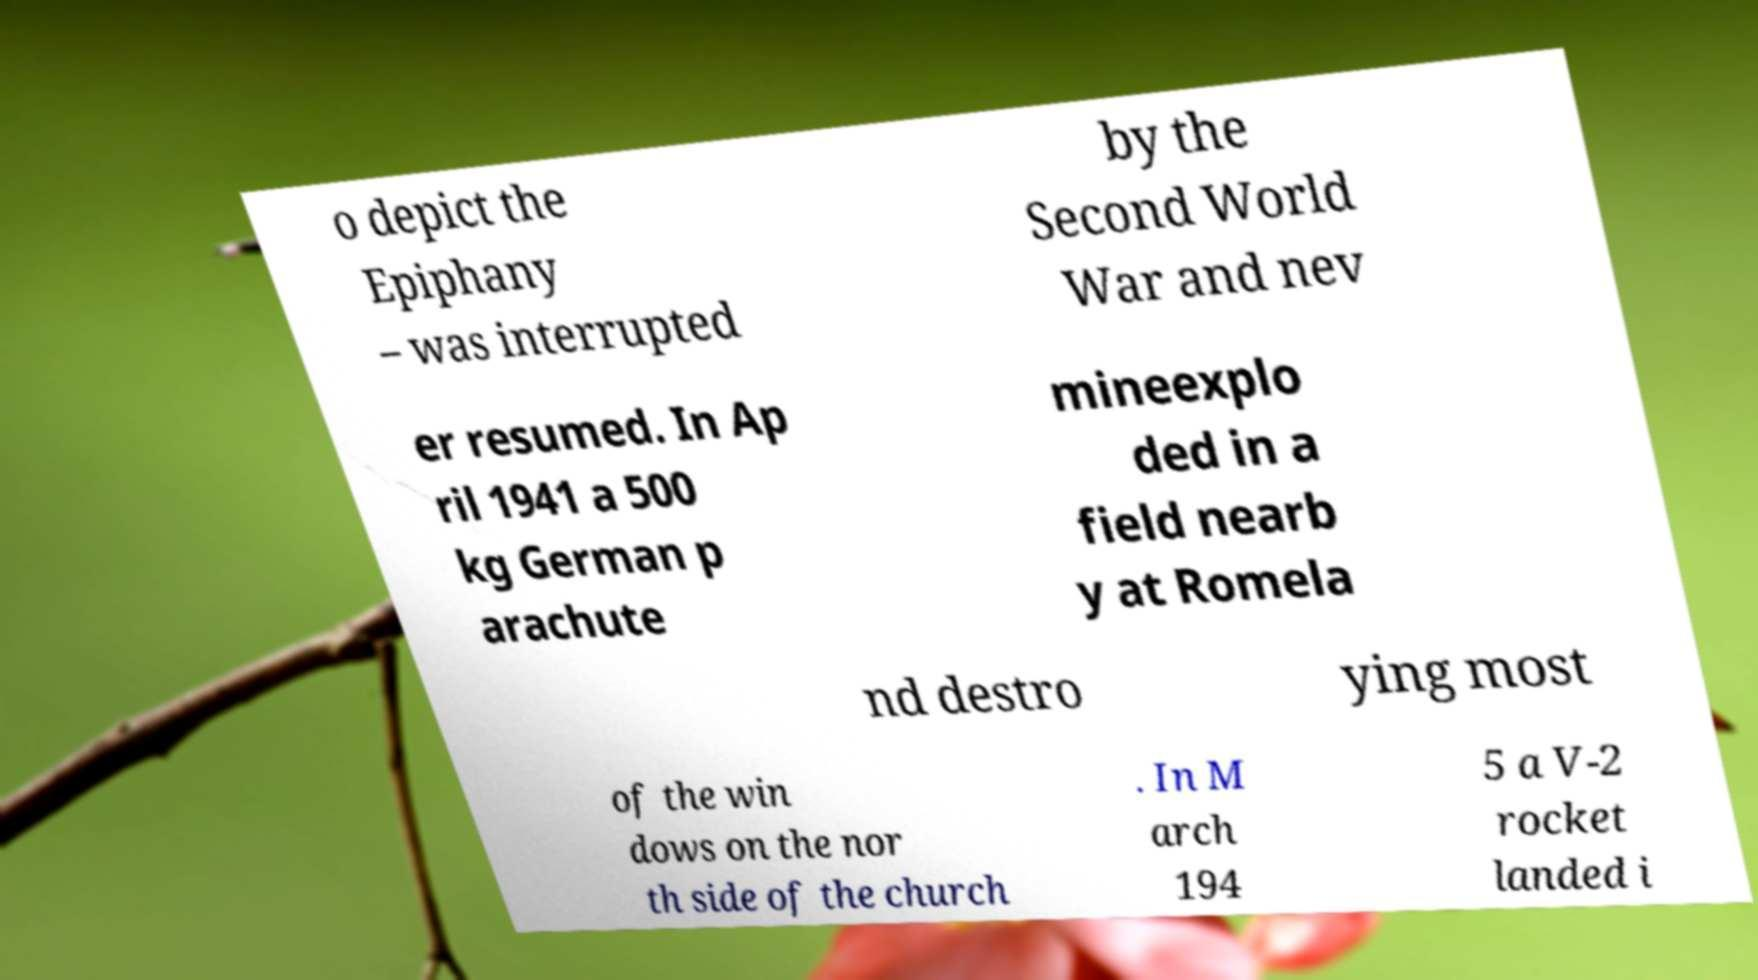Could you assist in decoding the text presented in this image and type it out clearly? o depict the Epiphany – was interrupted by the Second World War and nev er resumed. In Ap ril 1941 a 500 kg German p arachute mineexplo ded in a field nearb y at Romela nd destro ying most of the win dows on the nor th side of the church . In M arch 194 5 a V-2 rocket landed i 